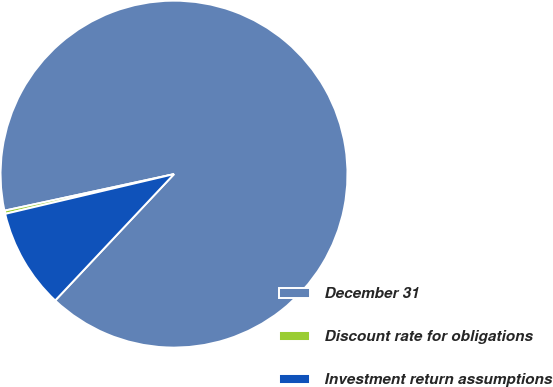<chart> <loc_0><loc_0><loc_500><loc_500><pie_chart><fcel>December 31<fcel>Discount rate for obligations<fcel>Investment return assumptions<nl><fcel>90.38%<fcel>0.3%<fcel>9.31%<nl></chart> 